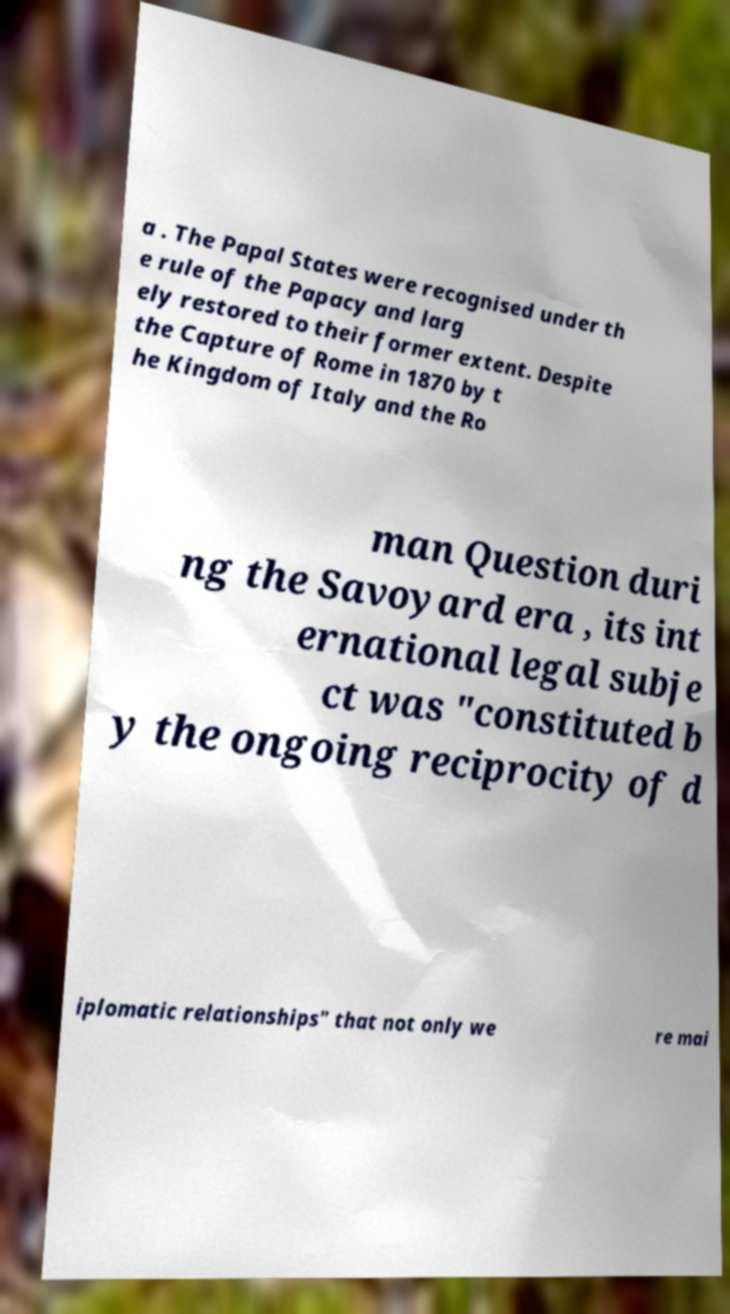Can you read and provide the text displayed in the image?This photo seems to have some interesting text. Can you extract and type it out for me? a . The Papal States were recognised under th e rule of the Papacy and larg ely restored to their former extent. Despite the Capture of Rome in 1870 by t he Kingdom of Italy and the Ro man Question duri ng the Savoyard era , its int ernational legal subje ct was "constituted b y the ongoing reciprocity of d iplomatic relationships" that not only we re mai 